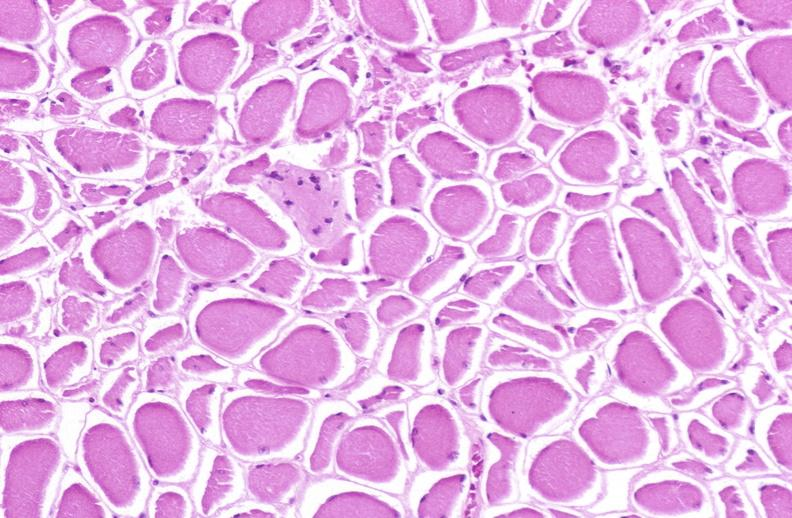s spinal column present?
Answer the question using a single word or phrase. No 